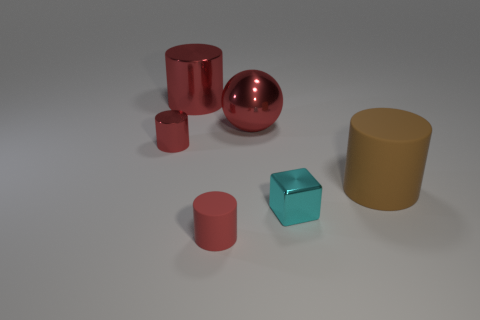How many red cylinders must be subtracted to get 1 red cylinders? 2 Subtract all brown cylinders. How many cylinders are left? 3 Subtract all brown cylinders. How many cylinders are left? 3 Add 1 brown things. How many objects exist? 7 Subtract all blue cubes. How many red cylinders are left? 3 Subtract all big shiny spheres. Subtract all tiny matte cylinders. How many objects are left? 4 Add 3 small metallic objects. How many small metallic objects are left? 5 Add 3 red cylinders. How many red cylinders exist? 6 Subtract 0 red blocks. How many objects are left? 6 Subtract all balls. How many objects are left? 5 